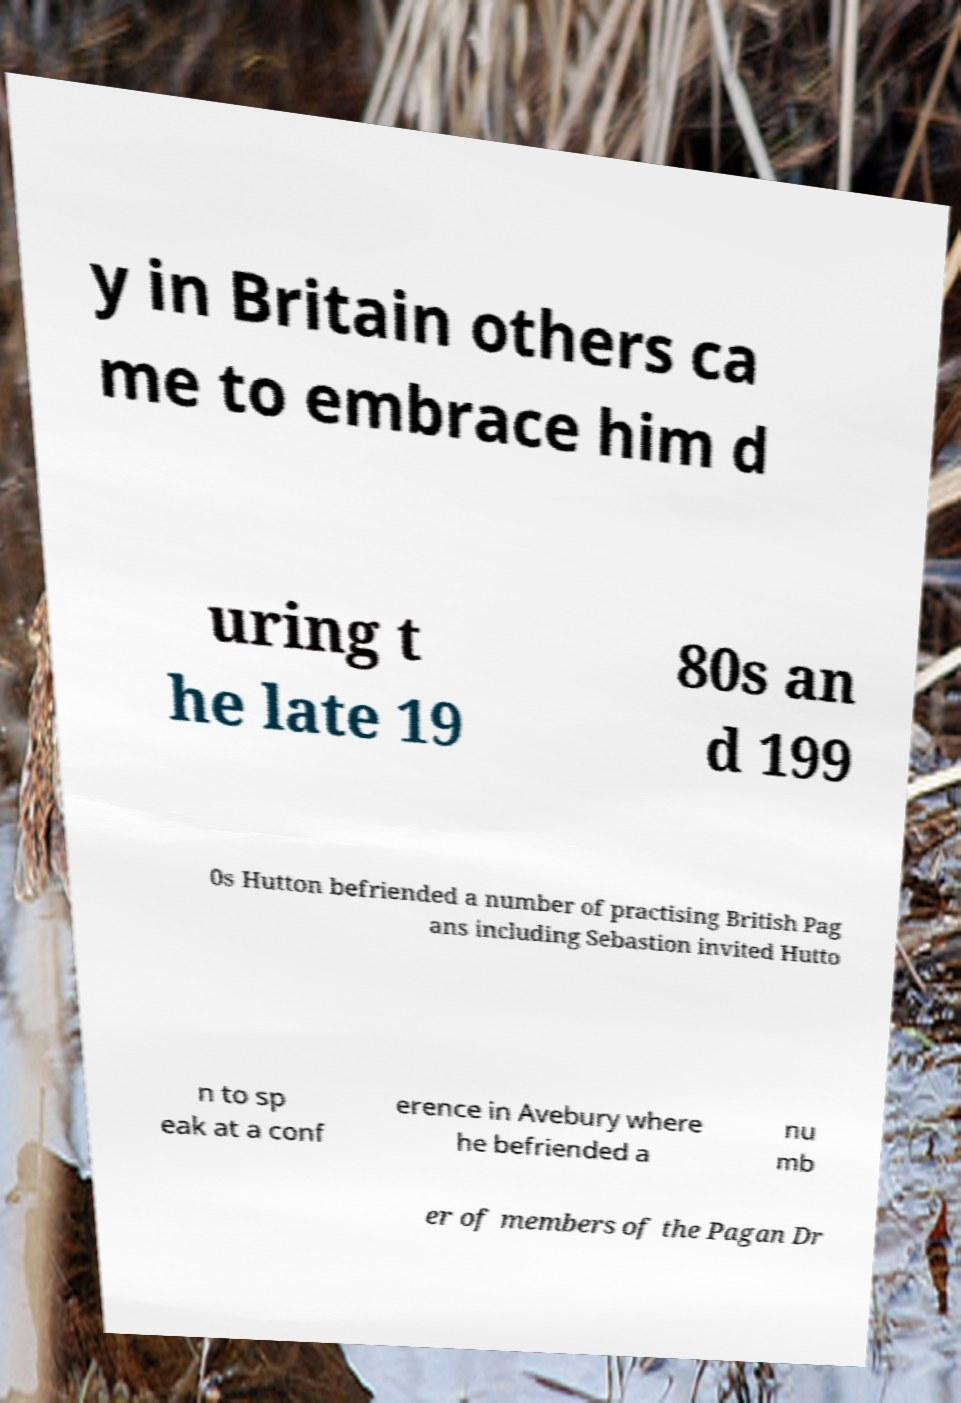Can you accurately transcribe the text from the provided image for me? y in Britain others ca me to embrace him d uring t he late 19 80s an d 199 0s Hutton befriended a number of practising British Pag ans including Sebastion invited Hutto n to sp eak at a conf erence in Avebury where he befriended a nu mb er of members of the Pagan Dr 